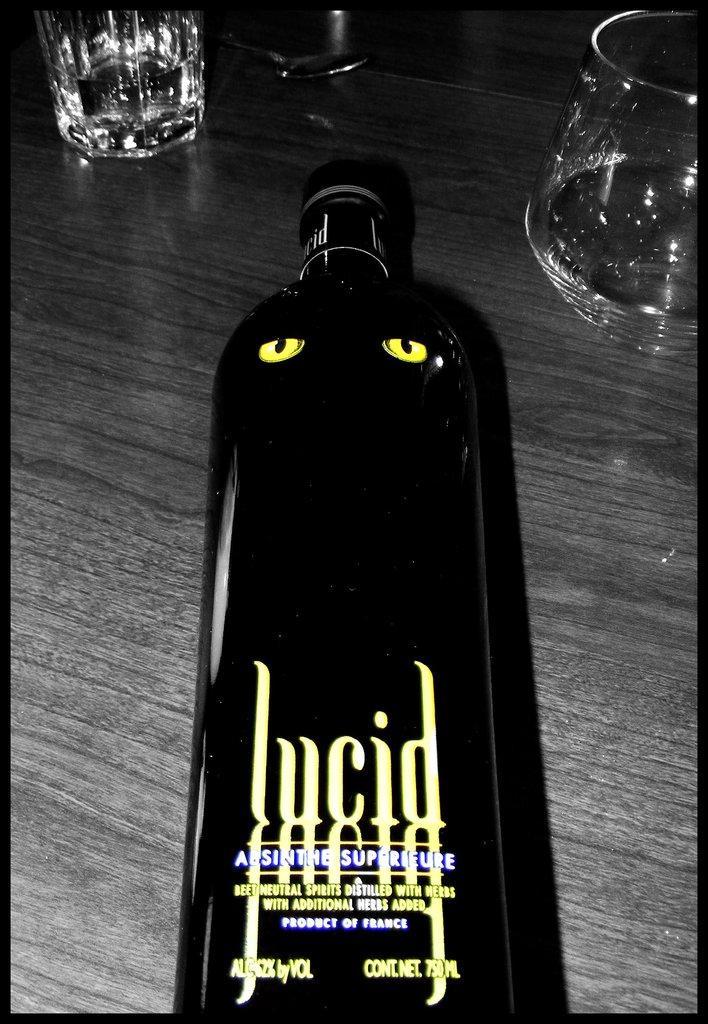Can you describe this image briefly? In the foreground of this image, there is a bottle on the wooden surface. At the top, there are glasses. 